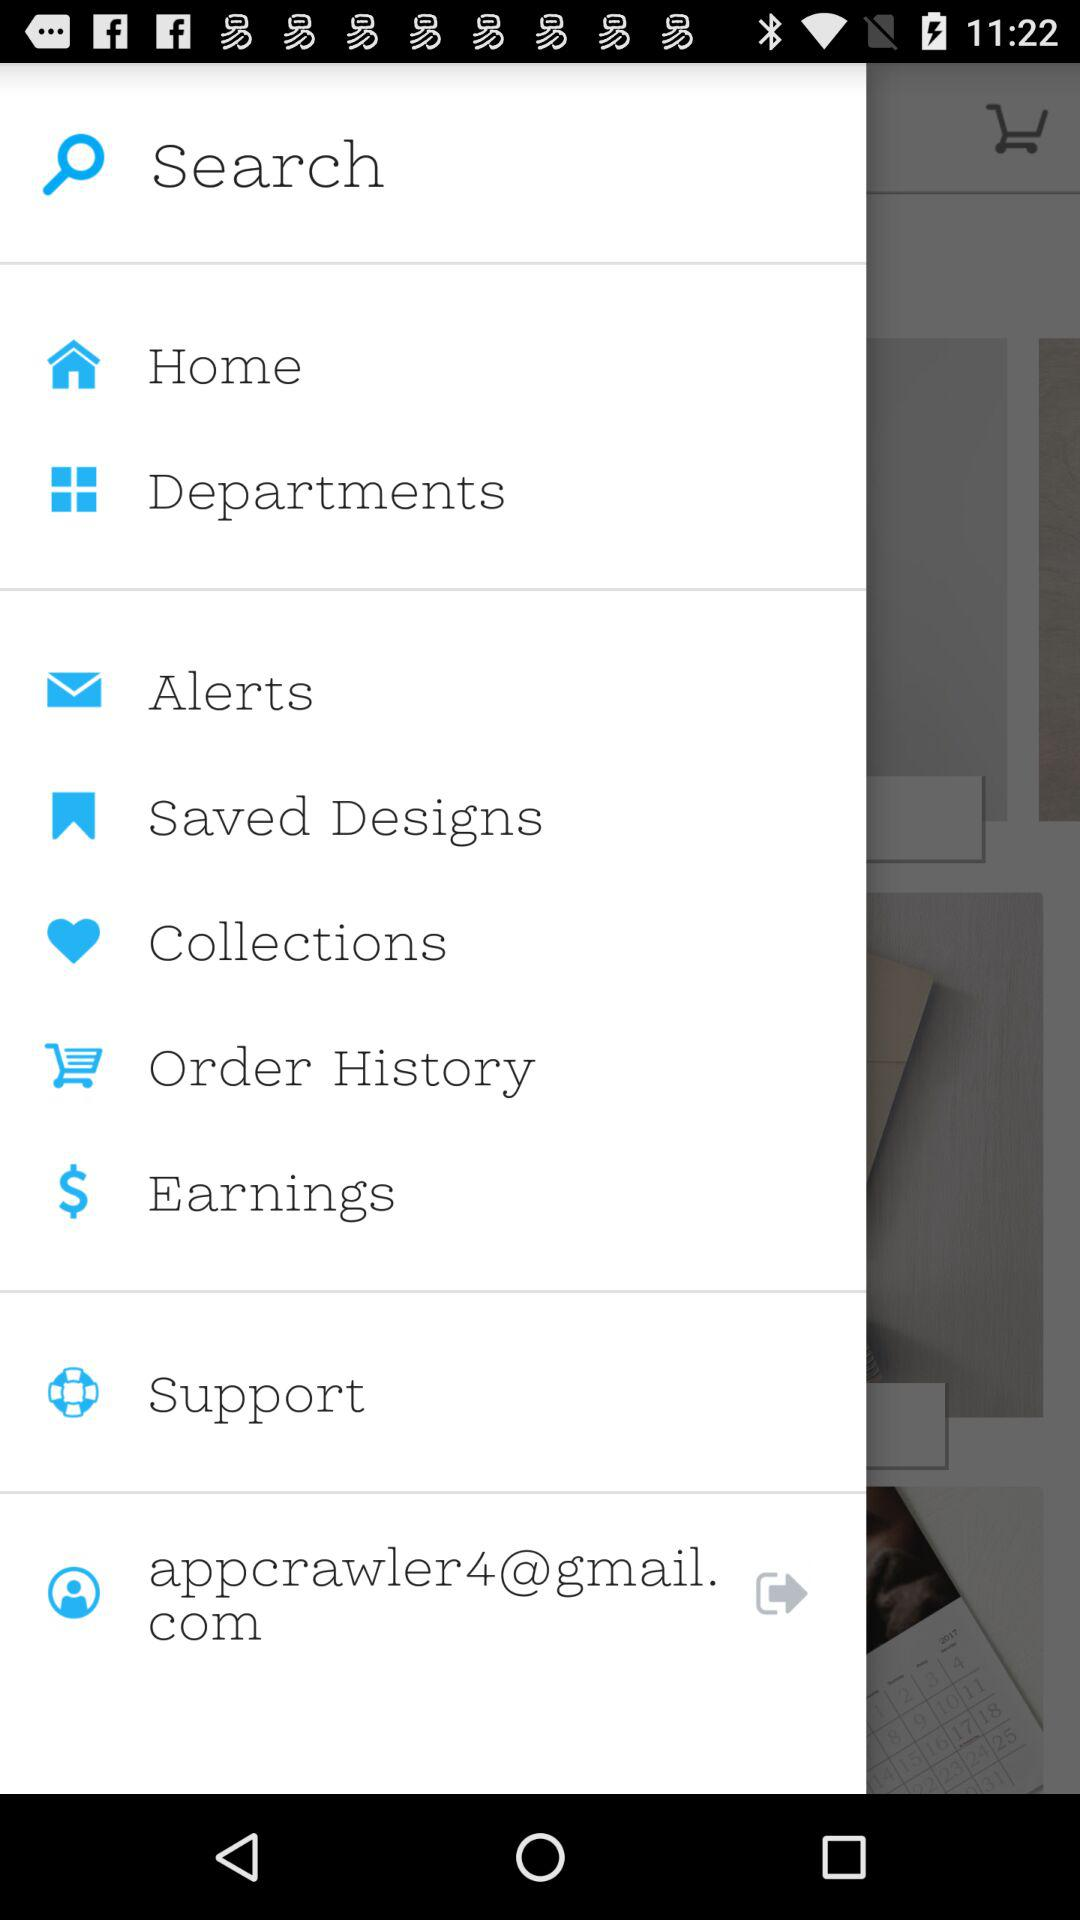Which items are found in the order history?
When the provided information is insufficient, respond with <no answer>. <no answer> 